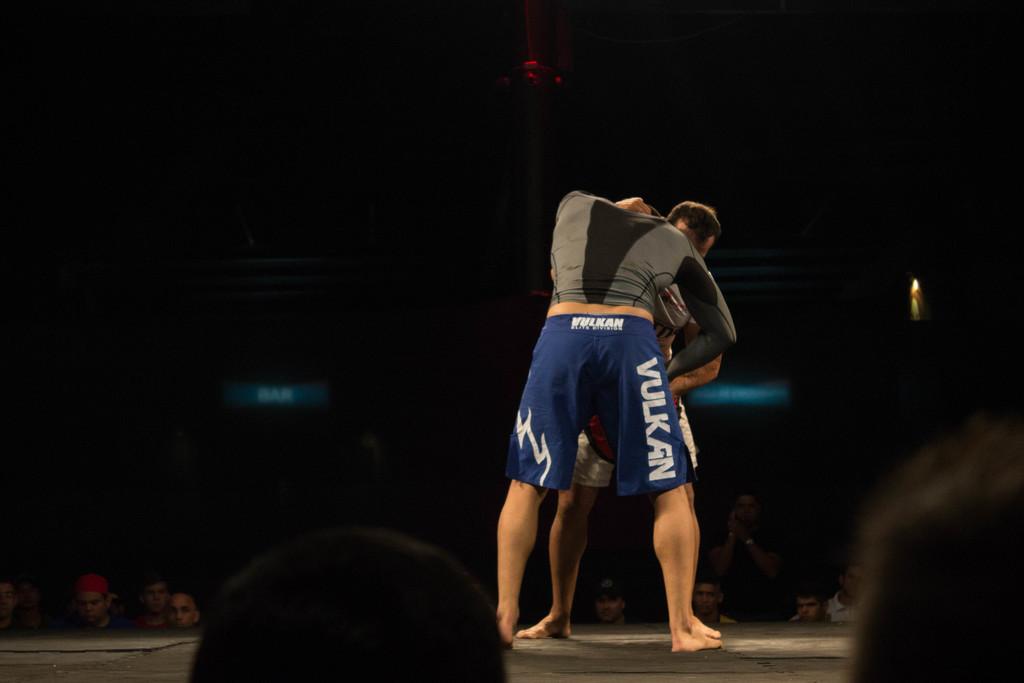What is written across his butt?
Keep it short and to the point. Vulkan. 